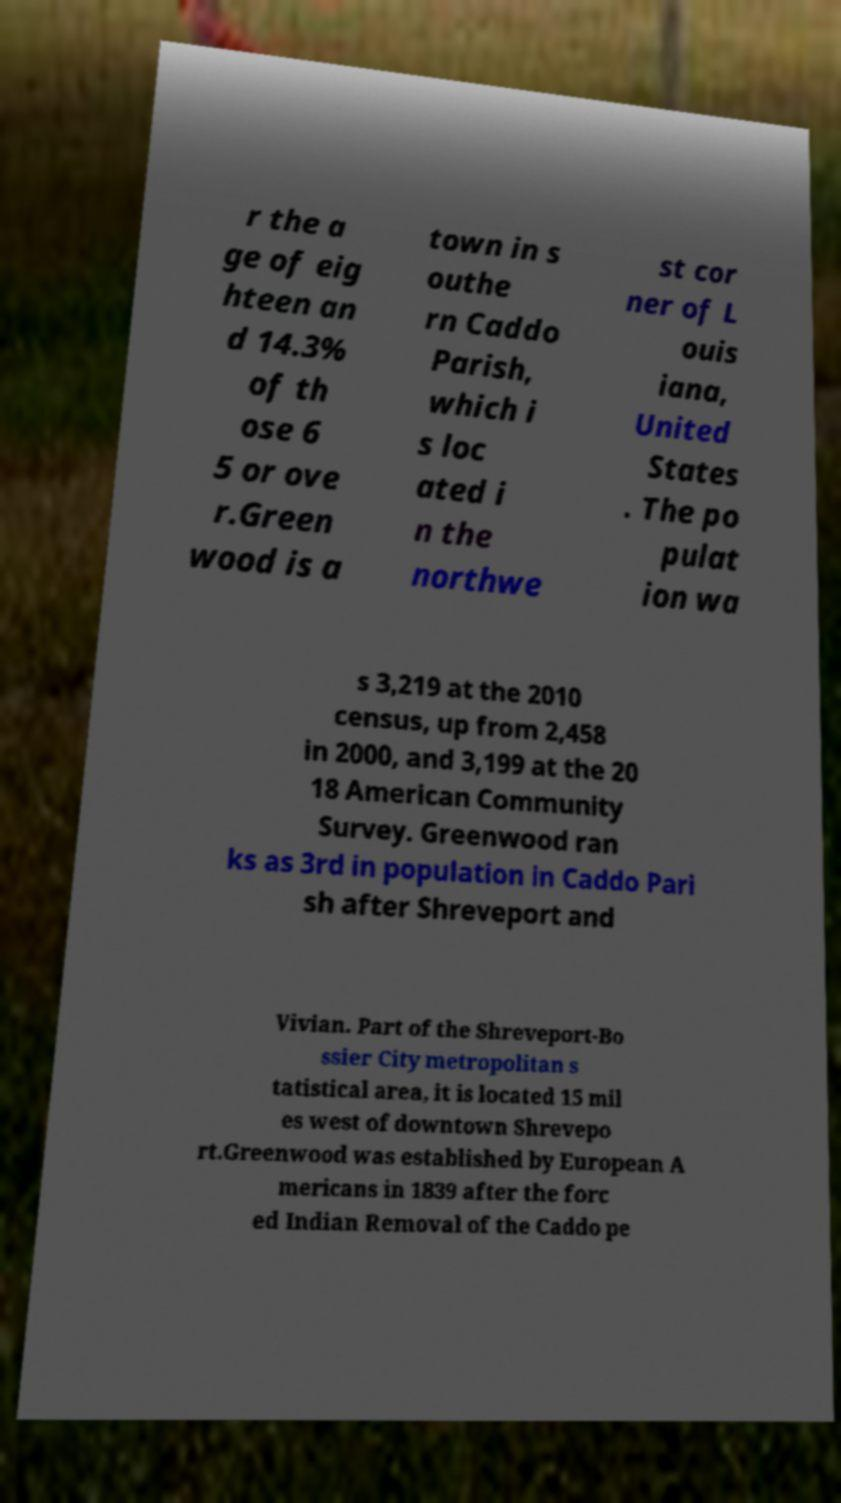I need the written content from this picture converted into text. Can you do that? r the a ge of eig hteen an d 14.3% of th ose 6 5 or ove r.Green wood is a town in s outhe rn Caddo Parish, which i s loc ated i n the northwe st cor ner of L ouis iana, United States . The po pulat ion wa s 3,219 at the 2010 census, up from 2,458 in 2000, and 3,199 at the 20 18 American Community Survey. Greenwood ran ks as 3rd in population in Caddo Pari sh after Shreveport and Vivian. Part of the Shreveport-Bo ssier City metropolitan s tatistical area, it is located 15 mil es west of downtown Shrevepo rt.Greenwood was established by European A mericans in 1839 after the forc ed Indian Removal of the Caddo pe 